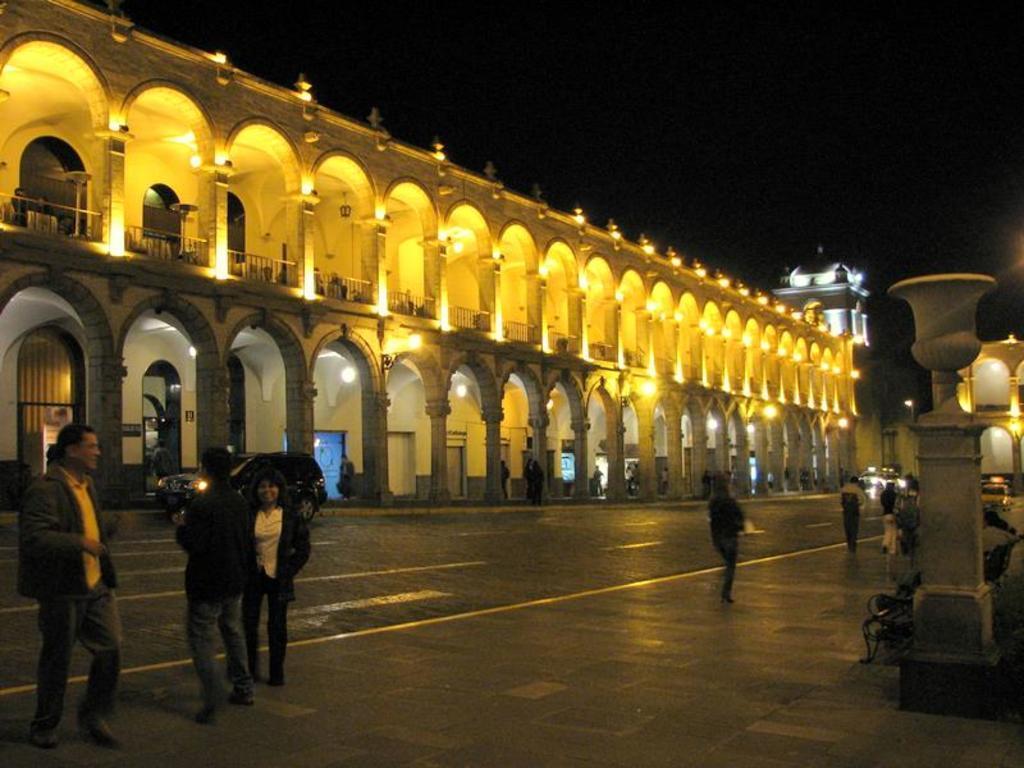How would you summarize this image in a sentence or two? In this image, I can see the buildings with lights. On the right side of the image, I can see a pillar and a bench. There are vehicles on the road, few people standing and few people walking. There is a dark background. 